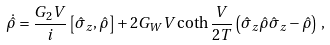Convert formula to latex. <formula><loc_0><loc_0><loc_500><loc_500>\dot { \hat { \rho } } = \frac { G _ { 2 } V } { i } \left [ \hat { \sigma } _ { z } , \hat { \rho } \right ] + 2 G _ { W } V \coth \frac { V } { 2 T } \left ( \hat { \sigma } _ { z } \hat { \rho } \hat { \sigma } _ { z } - \hat { \rho } \right ) \, ,</formula> 